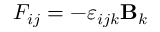Convert formula to latex. <formula><loc_0><loc_0><loc_500><loc_500>F _ { i j } = - \varepsilon _ { i j k } { B } _ { k }</formula> 